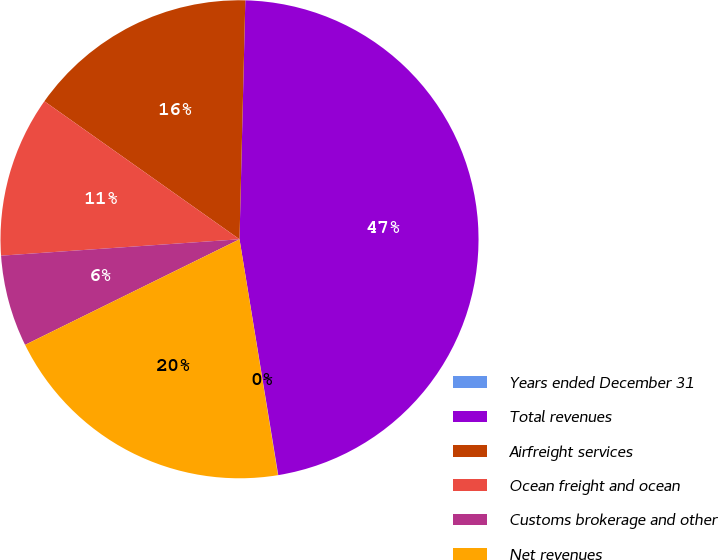Convert chart. <chart><loc_0><loc_0><loc_500><loc_500><pie_chart><fcel>Years ended December 31<fcel>Total revenues<fcel>Airfreight services<fcel>Ocean freight and ocean<fcel>Customs brokerage and other<fcel>Net revenues<nl><fcel>0.02%<fcel>47.02%<fcel>15.59%<fcel>10.89%<fcel>6.19%<fcel>20.29%<nl></chart> 